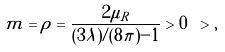<formula> <loc_0><loc_0><loc_500><loc_500>m = \rho = \frac { 2 \mu _ { R } } { ( 3 \lambda ) / ( 8 \pi ) - 1 } > 0 \ > ,</formula> 